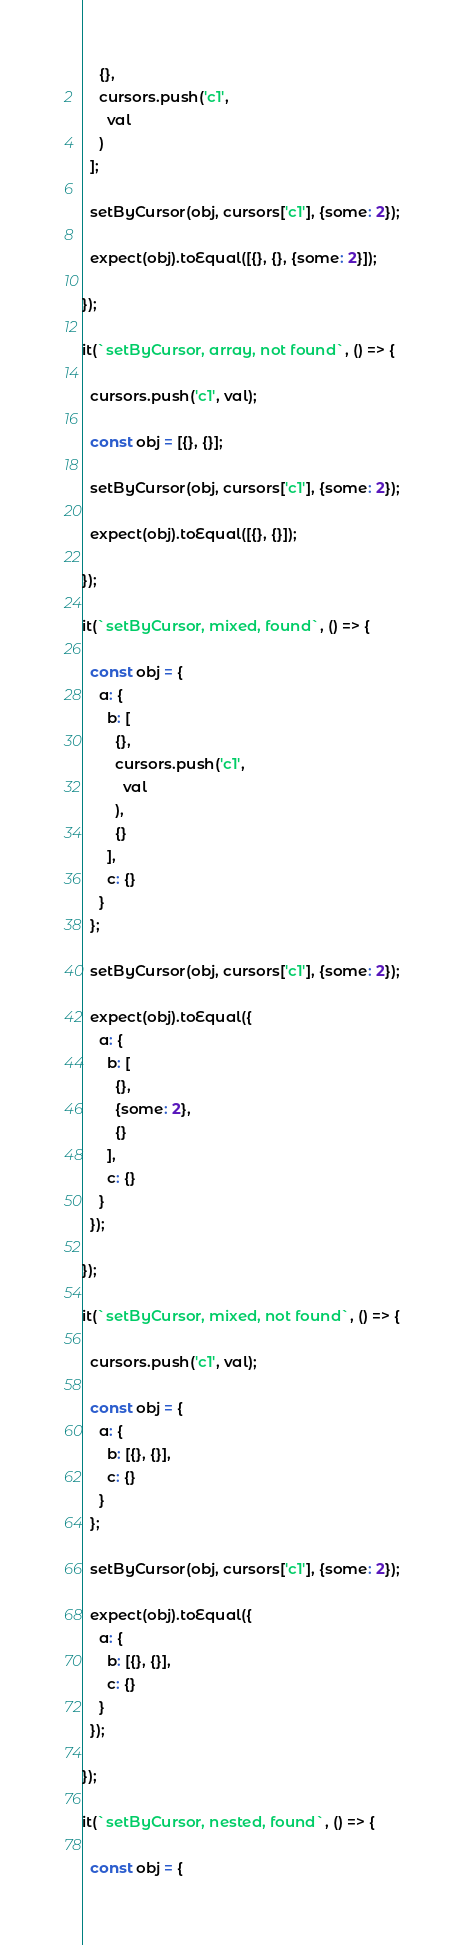Convert code to text. <code><loc_0><loc_0><loc_500><loc_500><_JavaScript_>    {},
    cursors.push('c1',
      val
    )
  ];

  setByCursor(obj, cursors['c1'], {some: 2});

  expect(obj).toEqual([{}, {}, {some: 2}]);

});

it(`setByCursor, array, not found`, () => {

  cursors.push('c1', val);

  const obj = [{}, {}];

  setByCursor(obj, cursors['c1'], {some: 2});

  expect(obj).toEqual([{}, {}]);

});

it(`setByCursor, mixed, found`, () => {

  const obj = {
    a: {
      b: [
        {},
        cursors.push('c1',
          val
        ),
        {}
      ],
      c: {}
    }
  };

  setByCursor(obj, cursors['c1'], {some: 2});

  expect(obj).toEqual({
    a: {
      b: [
        {},
        {some: 2},
        {}
      ],
      c: {}
    }
  });

});

it(`setByCursor, mixed, not found`, () => {

  cursors.push('c1', val);

  const obj = {
    a: {
      b: [{}, {}],
      c: {}
    }
  };

  setByCursor(obj, cursors['c1'], {some: 2});

  expect(obj).toEqual({
    a: {
      b: [{}, {}],
      c: {}
    }
  });

});

it(`setByCursor, nested, found`, () => {

  const obj = {</code> 